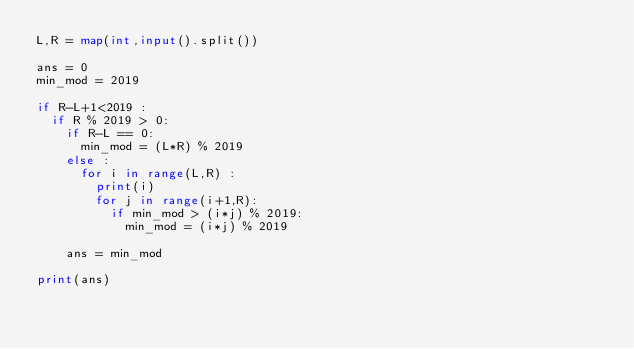Convert code to text. <code><loc_0><loc_0><loc_500><loc_500><_Python_>L,R = map(int,input().split())

ans = 0
min_mod = 2019

if R-L+1<2019 :
  if R % 2019 > 0:
    if R-L == 0:
      min_mod = (L*R) % 2019
    else :
      for i in range(L,R) :
        print(i)
        for j in range(i+1,R):
          if min_mod > (i*j) % 2019:
            min_mod = (i*j) % 2019

    ans = min_mod
    
print(ans)</code> 